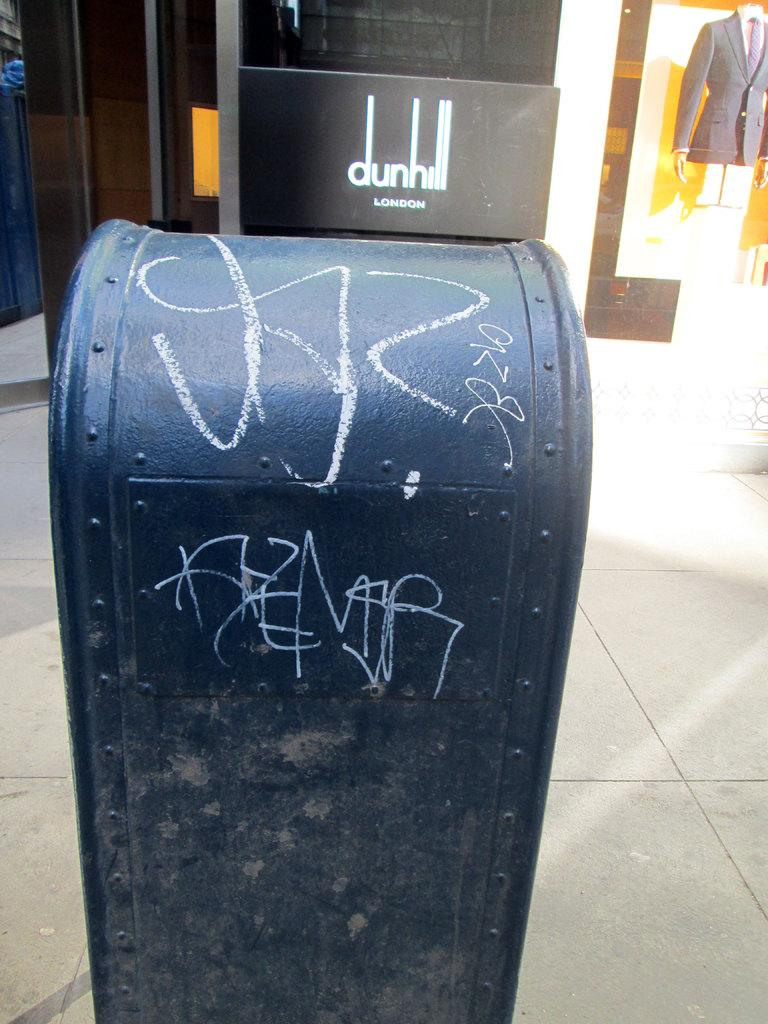<image>
Describe the image concisely. A tagged mailbox sits in front of Dunhill London. 